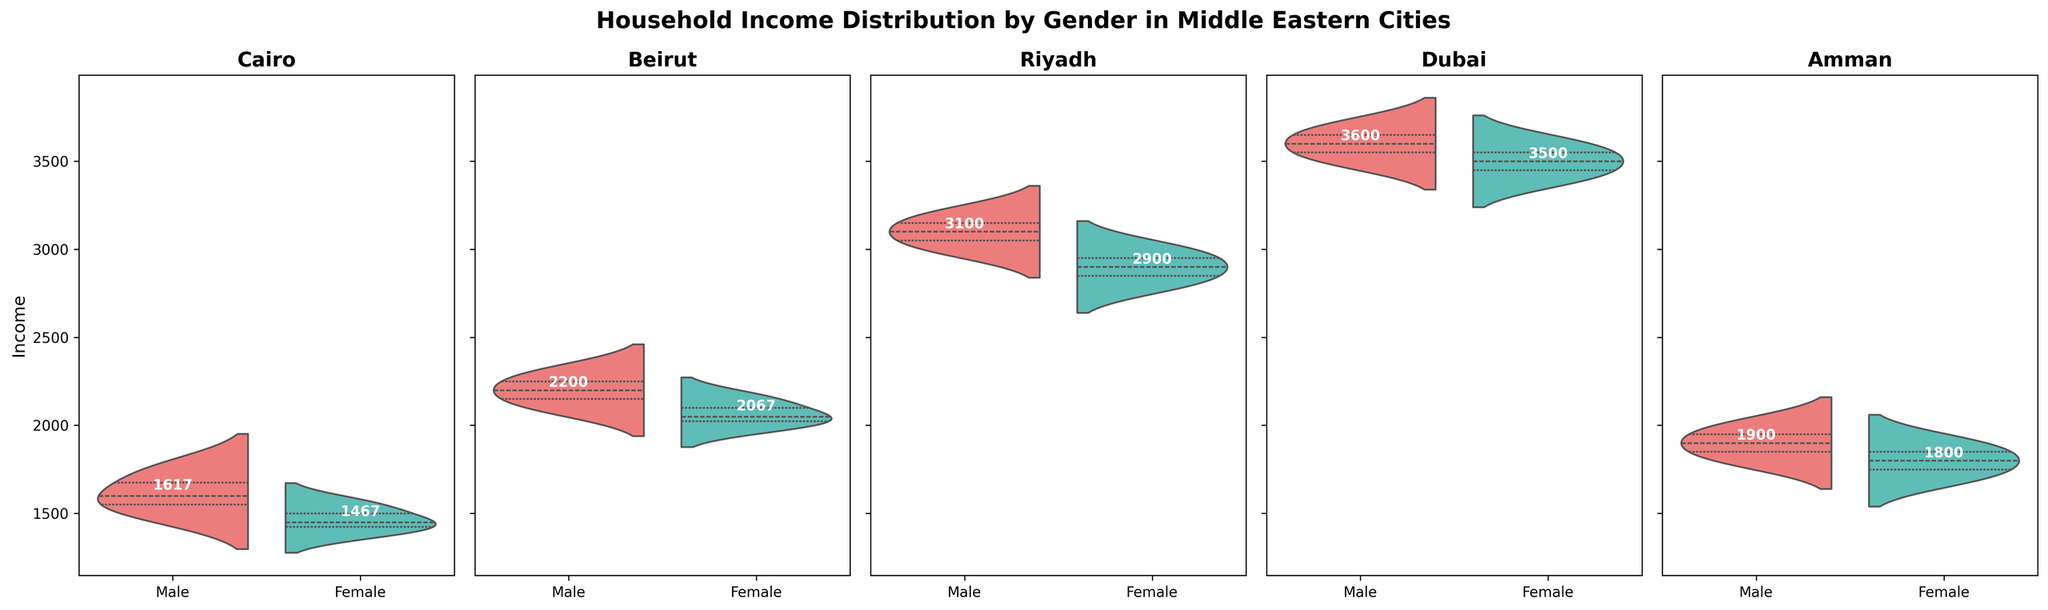which city has the lowest average female income? Comparing the average female incomes, Cairo has the lowest average income among females. The average incomes are represented by the text values in the plot.
Answer: Cairo What is the average male income in Riyadh? The average male income in Riyadh can be found by looking at the labeled mean value for males in Riyadh. The mean income is shown as text in the plot.
Answer: 3100 Which city has the highest male income? By comparing the average male incomes across all cities, Dubai stands out with the highest average male income. The average incomes are displayed as text values in the plot.
Answer: Dubai How does the average female income in Amman compare to the average female income in Beirut? The average incomes are displayed on the plot as text values. Beirut's average female income is 2067, while Amman's is 1800. Beirut's average female income is higher.
Answer: Beirut has a higher average female income In which city is the income distribution for males more spread out compared to females? Observing the widths of the violin plots for each gender in each city, we can see in Dubai, the male income distribution is visibly more spread out compared to the female income distribution.
Answer: Dubai What is the purpose of the colors in the chart? The colors in the chart differentiate between male and female income distributions. One color represents males, and the other represents females, ensuring it's easy to compare between genders.
Answer: To differentiate between genders Can you find outliers in any gender in any city? Outliers in a violin plot are typically shown as distinct points outside the main distribution range. In this chart, no distinct outliers appear since the data seems evenly distributed and lacks extreme values.
Answer: No visible outliers Which city has the closest average incomes for males and females? By comparing the average incomes for males and females displayed in the plot, Riyadh shows the smallest difference between male (3100) and female (2900) incomes. The difference is 200, which is less compared to other cities.
Answer: Riyadh 